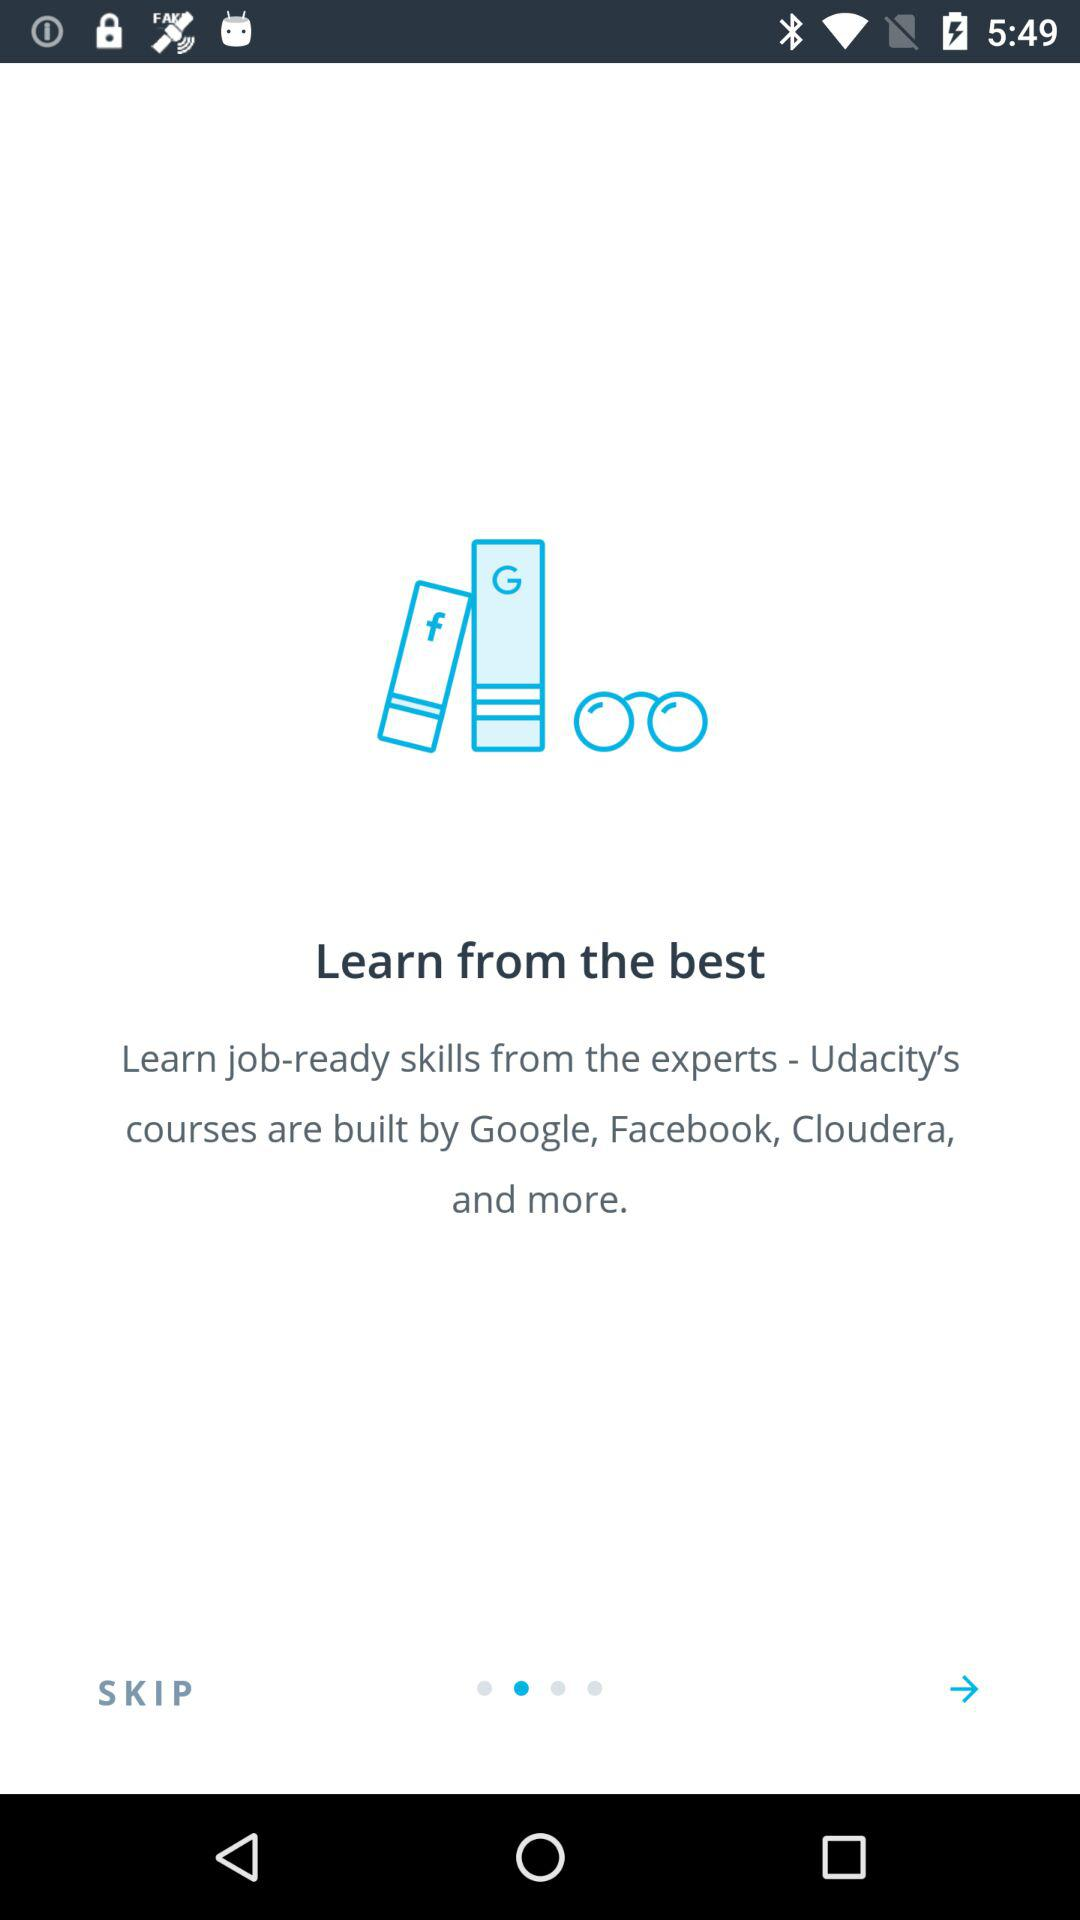Who built the courses in "Udacity"? The courses in "Udacity" are built by Google, Facebook, Cloudera and more. 